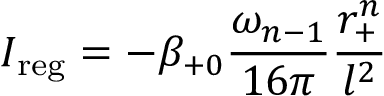Convert formula to latex. <formula><loc_0><loc_0><loc_500><loc_500>I _ { r e g } = - \beta _ { + 0 } \frac { \omega _ { n - 1 } } { 1 6 \pi } \frac { r _ { + } ^ { n } } { l ^ { 2 } }</formula> 